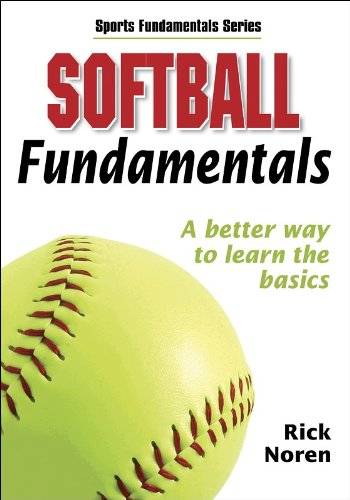Is this book related to Parenting & Relationships? No, this book is not related to 'Parenting & Relationships'. It is purely a sports instructional guide focusing on softball. 